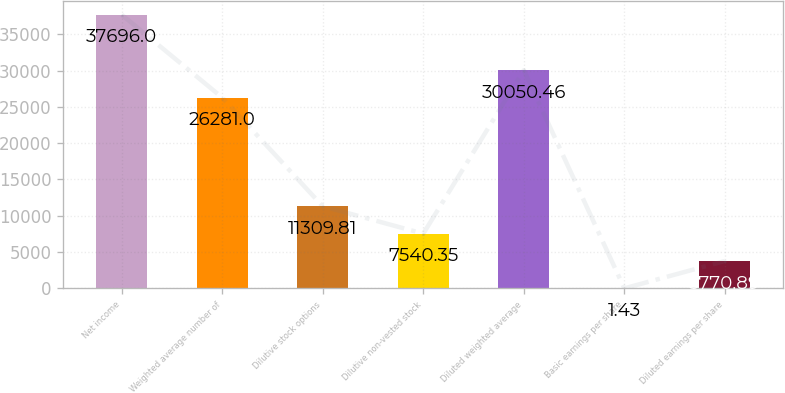Convert chart to OTSL. <chart><loc_0><loc_0><loc_500><loc_500><bar_chart><fcel>Net income<fcel>Weighted average number of<fcel>Dilutive stock options<fcel>Dilutive non-vested stock<fcel>Diluted weighted average<fcel>Basic earnings per share<fcel>Diluted earnings per share<nl><fcel>37696<fcel>26281<fcel>11309.8<fcel>7540.35<fcel>30050.5<fcel>1.43<fcel>3770.89<nl></chart> 